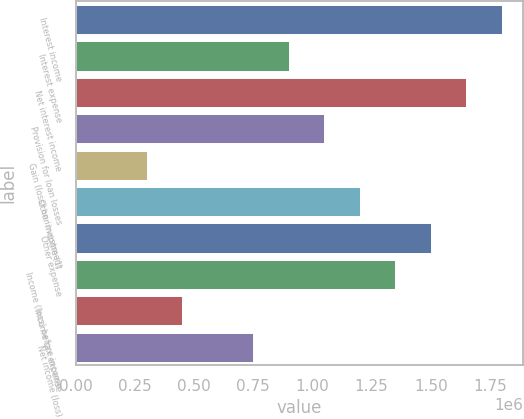<chart> <loc_0><loc_0><loc_500><loc_500><bar_chart><fcel>Interest income<fcel>Interest expense<fcel>Net interest income<fcel>Provision for loan losses<fcel>Gain (loss) on investment<fcel>Other income (1)<fcel>Other expense<fcel>Income (loss) before income<fcel>Income tax expense<fcel>Net income (loss)<nl><fcel>1.79922e+06<fcel>899608<fcel>1.64928e+06<fcel>1.04954e+06<fcel>299870<fcel>1.19948e+06<fcel>1.49935e+06<fcel>1.34941e+06<fcel>449805<fcel>749674<nl></chart> 